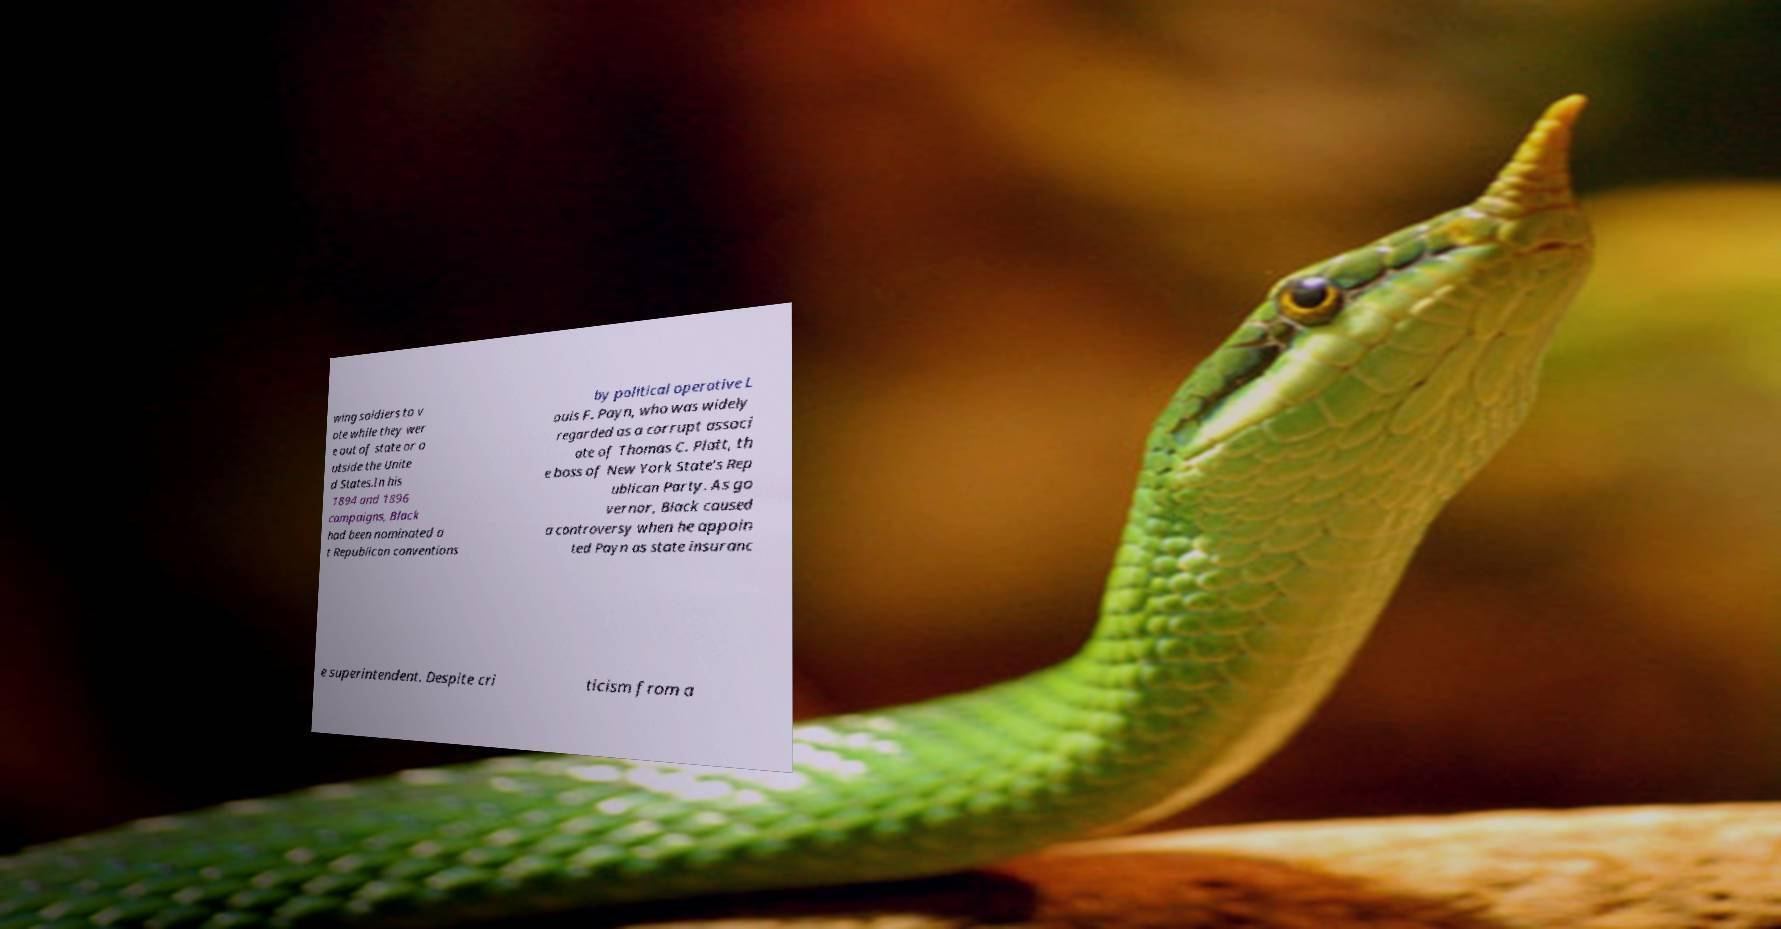Can you read and provide the text displayed in the image?This photo seems to have some interesting text. Can you extract and type it out for me? wing soldiers to v ote while they wer e out of state or o utside the Unite d States.In his 1894 and 1896 campaigns, Black had been nominated a t Republican conventions by political operative L ouis F. Payn, who was widely regarded as a corrupt associ ate of Thomas C. Platt, th e boss of New York State's Rep ublican Party. As go vernor, Black caused a controversy when he appoin ted Payn as state insuranc e superintendent. Despite cri ticism from a 